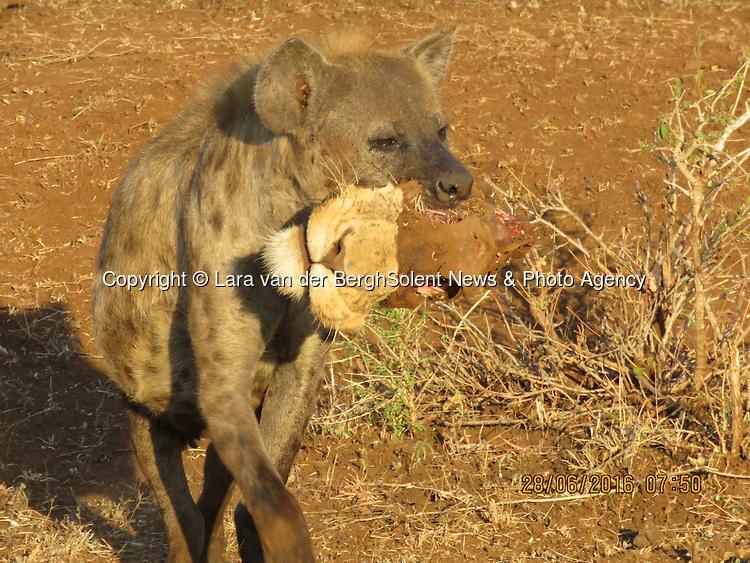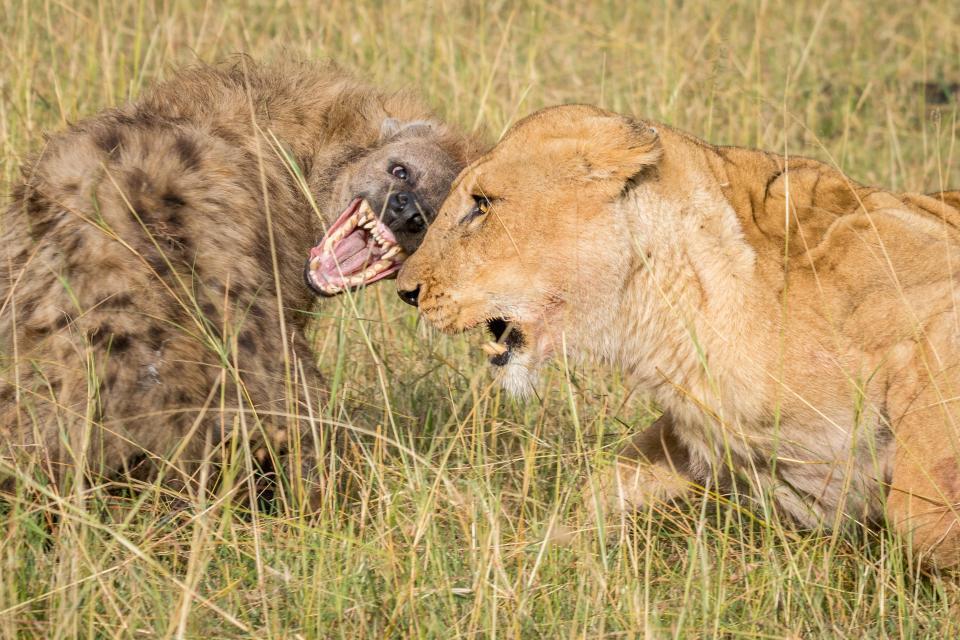The first image is the image on the left, the second image is the image on the right. For the images shown, is this caption "The hyena in the image on the left is carrying a small animal in its mouth." true? Answer yes or no. Yes. The first image is the image on the left, the second image is the image on the right. For the images shown, is this caption "An image shows one hyena, which is walking with at least part of an animal in its mouth." true? Answer yes or no. Yes. 